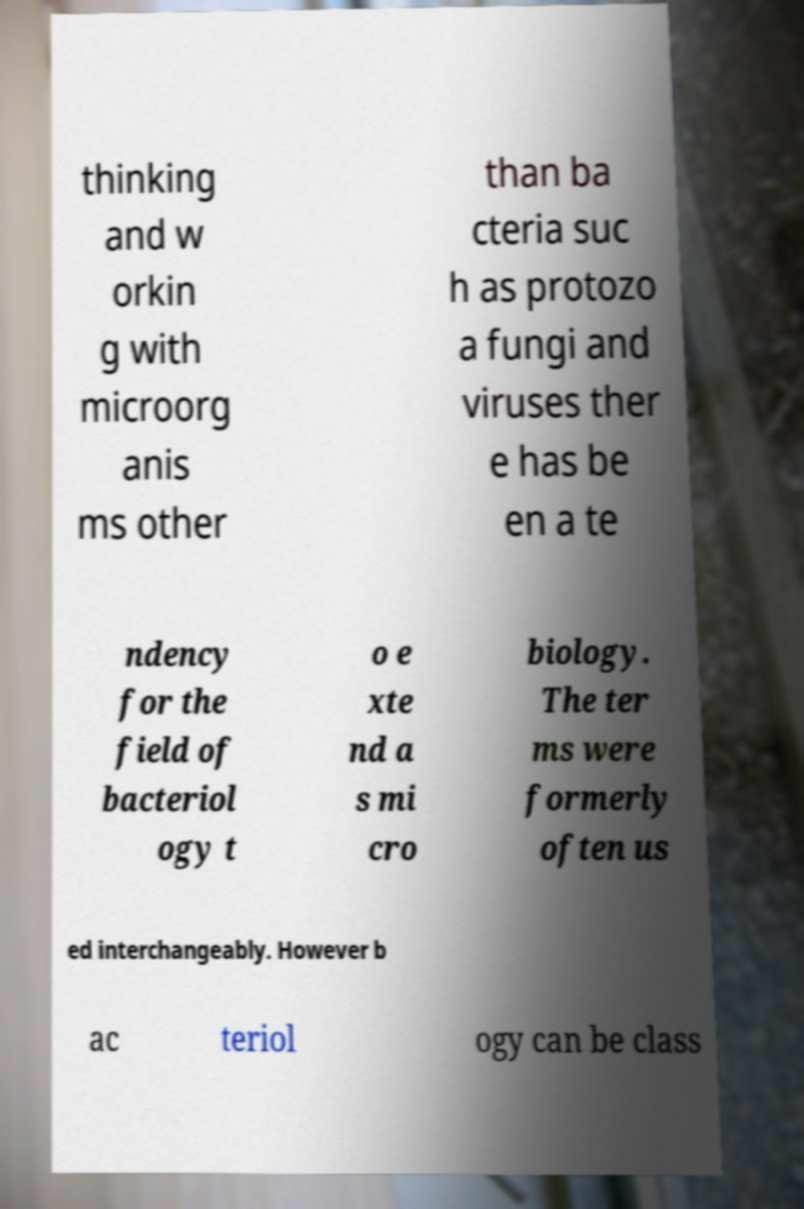For documentation purposes, I need the text within this image transcribed. Could you provide that? thinking and w orkin g with microorg anis ms other than ba cteria suc h as protozo a fungi and viruses ther e has be en a te ndency for the field of bacteriol ogy t o e xte nd a s mi cro biology. The ter ms were formerly often us ed interchangeably. However b ac teriol ogy can be class 